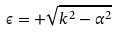<formula> <loc_0><loc_0><loc_500><loc_500>\epsilon = + \sqrt { k ^ { 2 } - \alpha ^ { 2 } }</formula> 